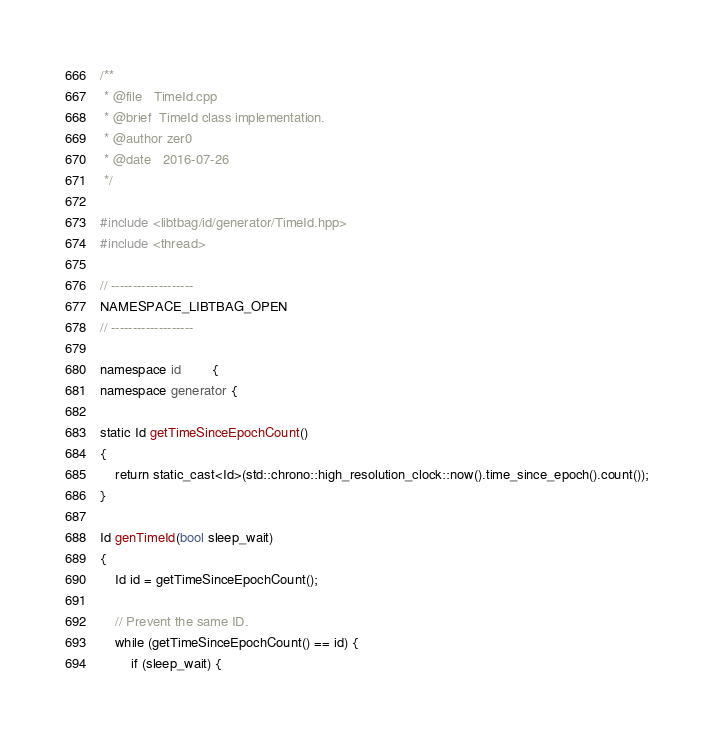<code> <loc_0><loc_0><loc_500><loc_500><_C++_>/**
 * @file   TimeId.cpp
 * @brief  TimeId class implementation.
 * @author zer0
 * @date   2016-07-26
 */

#include <libtbag/id/generator/TimeId.hpp>
#include <thread>

// -------------------
NAMESPACE_LIBTBAG_OPEN
// -------------------

namespace id        {
namespace generator {

static Id getTimeSinceEpochCount()
{
    return static_cast<Id>(std::chrono::high_resolution_clock::now().time_since_epoch().count());
}

Id genTimeId(bool sleep_wait)
{
    Id id = getTimeSinceEpochCount();

    // Prevent the same ID.
    while (getTimeSinceEpochCount() == id) {
        if (sleep_wait) {</code> 